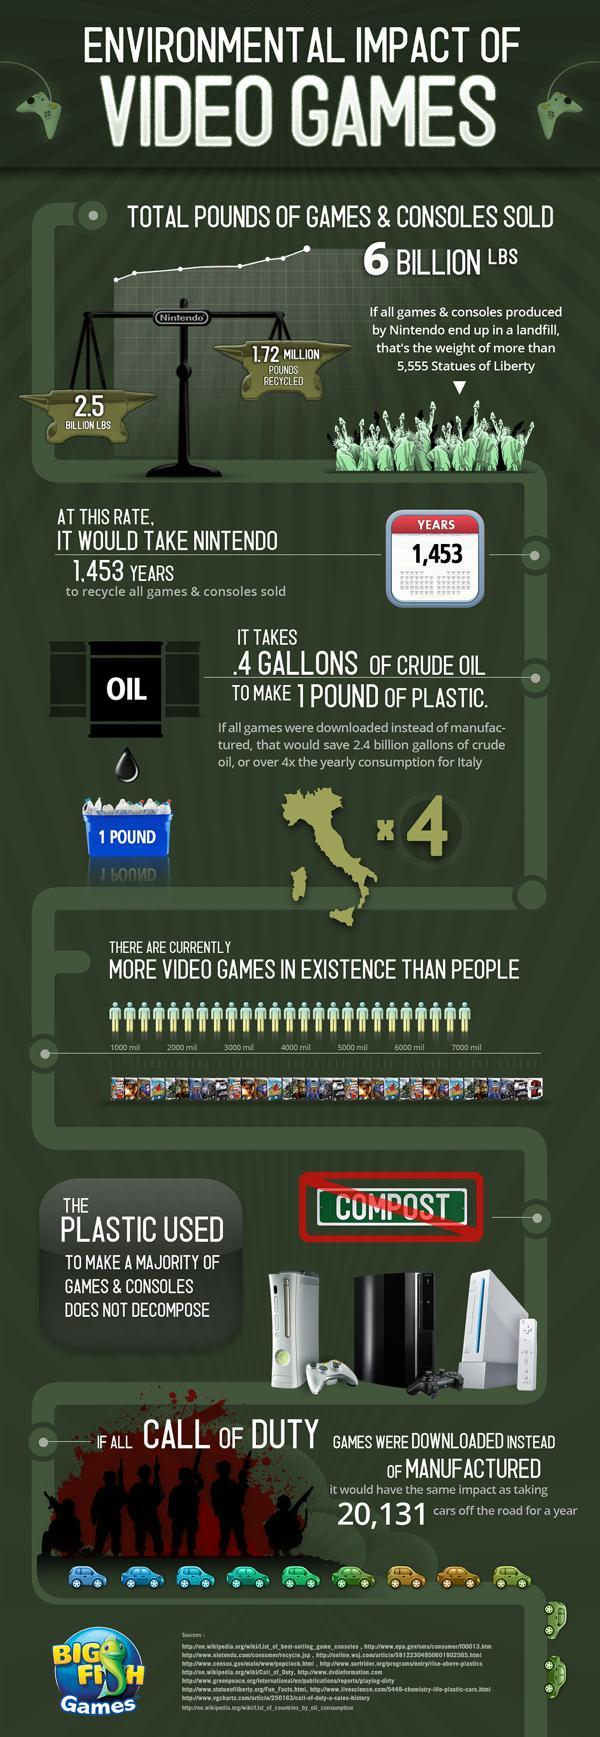What is the population of people in the world in millions?
Answer the question with a short phrase. 7000 mil 